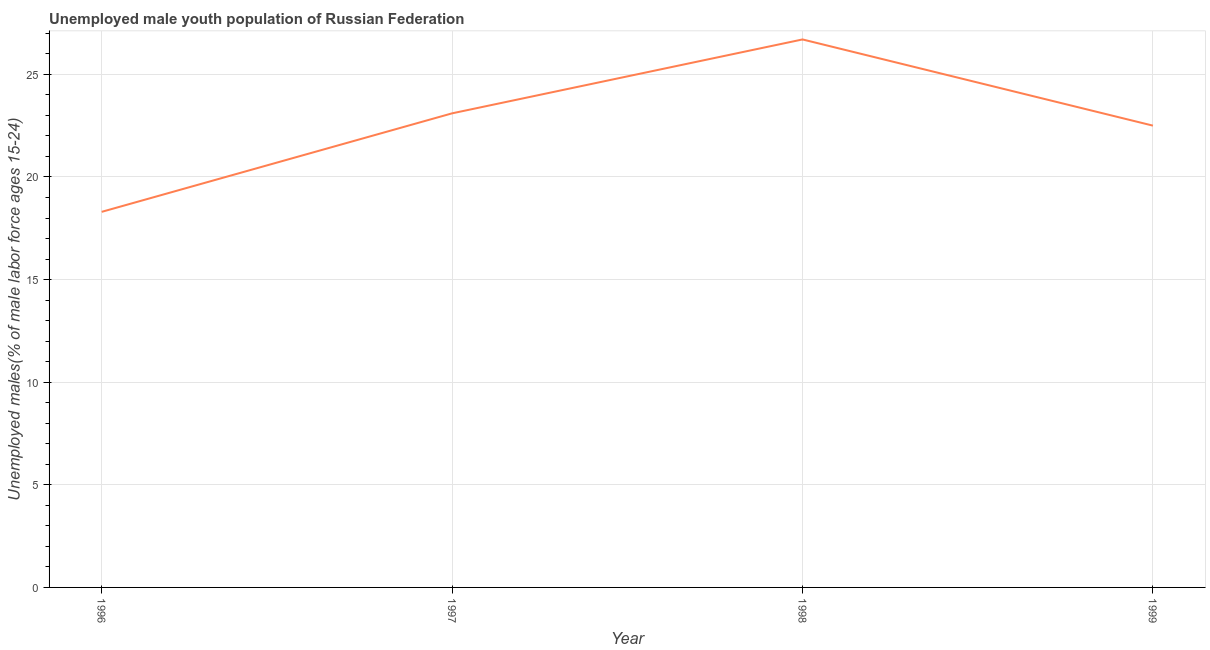What is the unemployed male youth in 1996?
Provide a succinct answer. 18.3. Across all years, what is the maximum unemployed male youth?
Keep it short and to the point. 26.7. Across all years, what is the minimum unemployed male youth?
Ensure brevity in your answer.  18.3. In which year was the unemployed male youth maximum?
Offer a very short reply. 1998. What is the sum of the unemployed male youth?
Provide a short and direct response. 90.6. What is the difference between the unemployed male youth in 1996 and 1999?
Give a very brief answer. -4.2. What is the average unemployed male youth per year?
Provide a short and direct response. 22.65. What is the median unemployed male youth?
Offer a very short reply. 22.8. What is the ratio of the unemployed male youth in 1997 to that in 1998?
Your answer should be very brief. 0.87. What is the difference between the highest and the second highest unemployed male youth?
Give a very brief answer. 3.6. Is the sum of the unemployed male youth in 1996 and 1997 greater than the maximum unemployed male youth across all years?
Your answer should be very brief. Yes. What is the difference between the highest and the lowest unemployed male youth?
Offer a very short reply. 8.4. Does the unemployed male youth monotonically increase over the years?
Offer a terse response. No. How many lines are there?
Your response must be concise. 1. How many years are there in the graph?
Offer a terse response. 4. What is the difference between two consecutive major ticks on the Y-axis?
Provide a succinct answer. 5. Are the values on the major ticks of Y-axis written in scientific E-notation?
Provide a short and direct response. No. Does the graph contain any zero values?
Offer a very short reply. No. Does the graph contain grids?
Your answer should be compact. Yes. What is the title of the graph?
Provide a succinct answer. Unemployed male youth population of Russian Federation. What is the label or title of the X-axis?
Keep it short and to the point. Year. What is the label or title of the Y-axis?
Offer a terse response. Unemployed males(% of male labor force ages 15-24). What is the Unemployed males(% of male labor force ages 15-24) of 1996?
Offer a very short reply. 18.3. What is the Unemployed males(% of male labor force ages 15-24) in 1997?
Keep it short and to the point. 23.1. What is the Unemployed males(% of male labor force ages 15-24) of 1998?
Provide a short and direct response. 26.7. What is the difference between the Unemployed males(% of male labor force ages 15-24) in 1996 and 1997?
Provide a succinct answer. -4.8. What is the difference between the Unemployed males(% of male labor force ages 15-24) in 1996 and 1999?
Provide a succinct answer. -4.2. What is the difference between the Unemployed males(% of male labor force ages 15-24) in 1998 and 1999?
Your answer should be compact. 4.2. What is the ratio of the Unemployed males(% of male labor force ages 15-24) in 1996 to that in 1997?
Keep it short and to the point. 0.79. What is the ratio of the Unemployed males(% of male labor force ages 15-24) in 1996 to that in 1998?
Your response must be concise. 0.69. What is the ratio of the Unemployed males(% of male labor force ages 15-24) in 1996 to that in 1999?
Give a very brief answer. 0.81. What is the ratio of the Unemployed males(% of male labor force ages 15-24) in 1997 to that in 1998?
Your answer should be very brief. 0.86. What is the ratio of the Unemployed males(% of male labor force ages 15-24) in 1998 to that in 1999?
Keep it short and to the point. 1.19. 